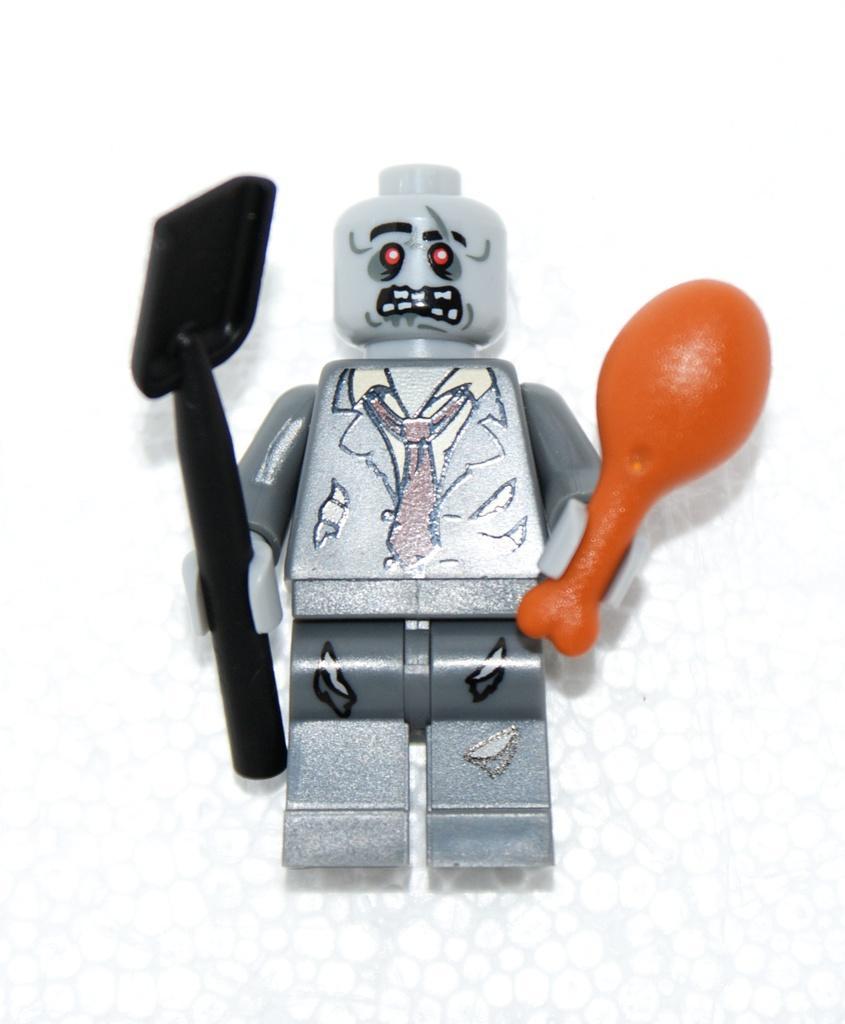Please provide a concise description of this image. In this picture we can see a doll. In his hand we can see a plastic balloon and spoon. 